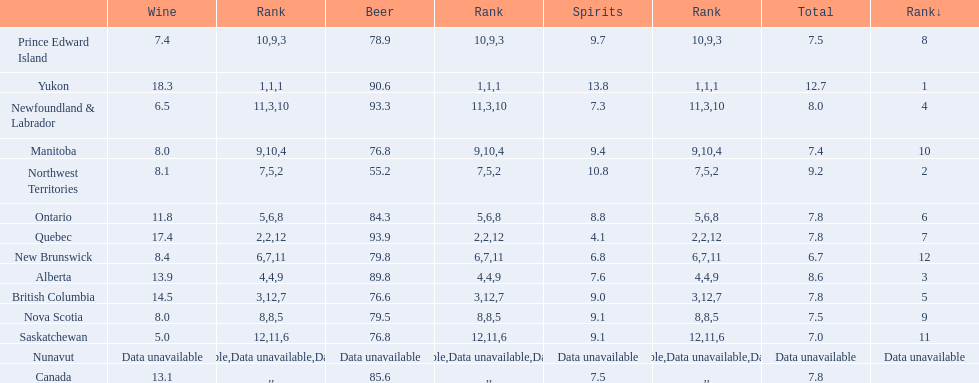Tell me province that drank more than 15 liters of wine. Yukon, Quebec. 